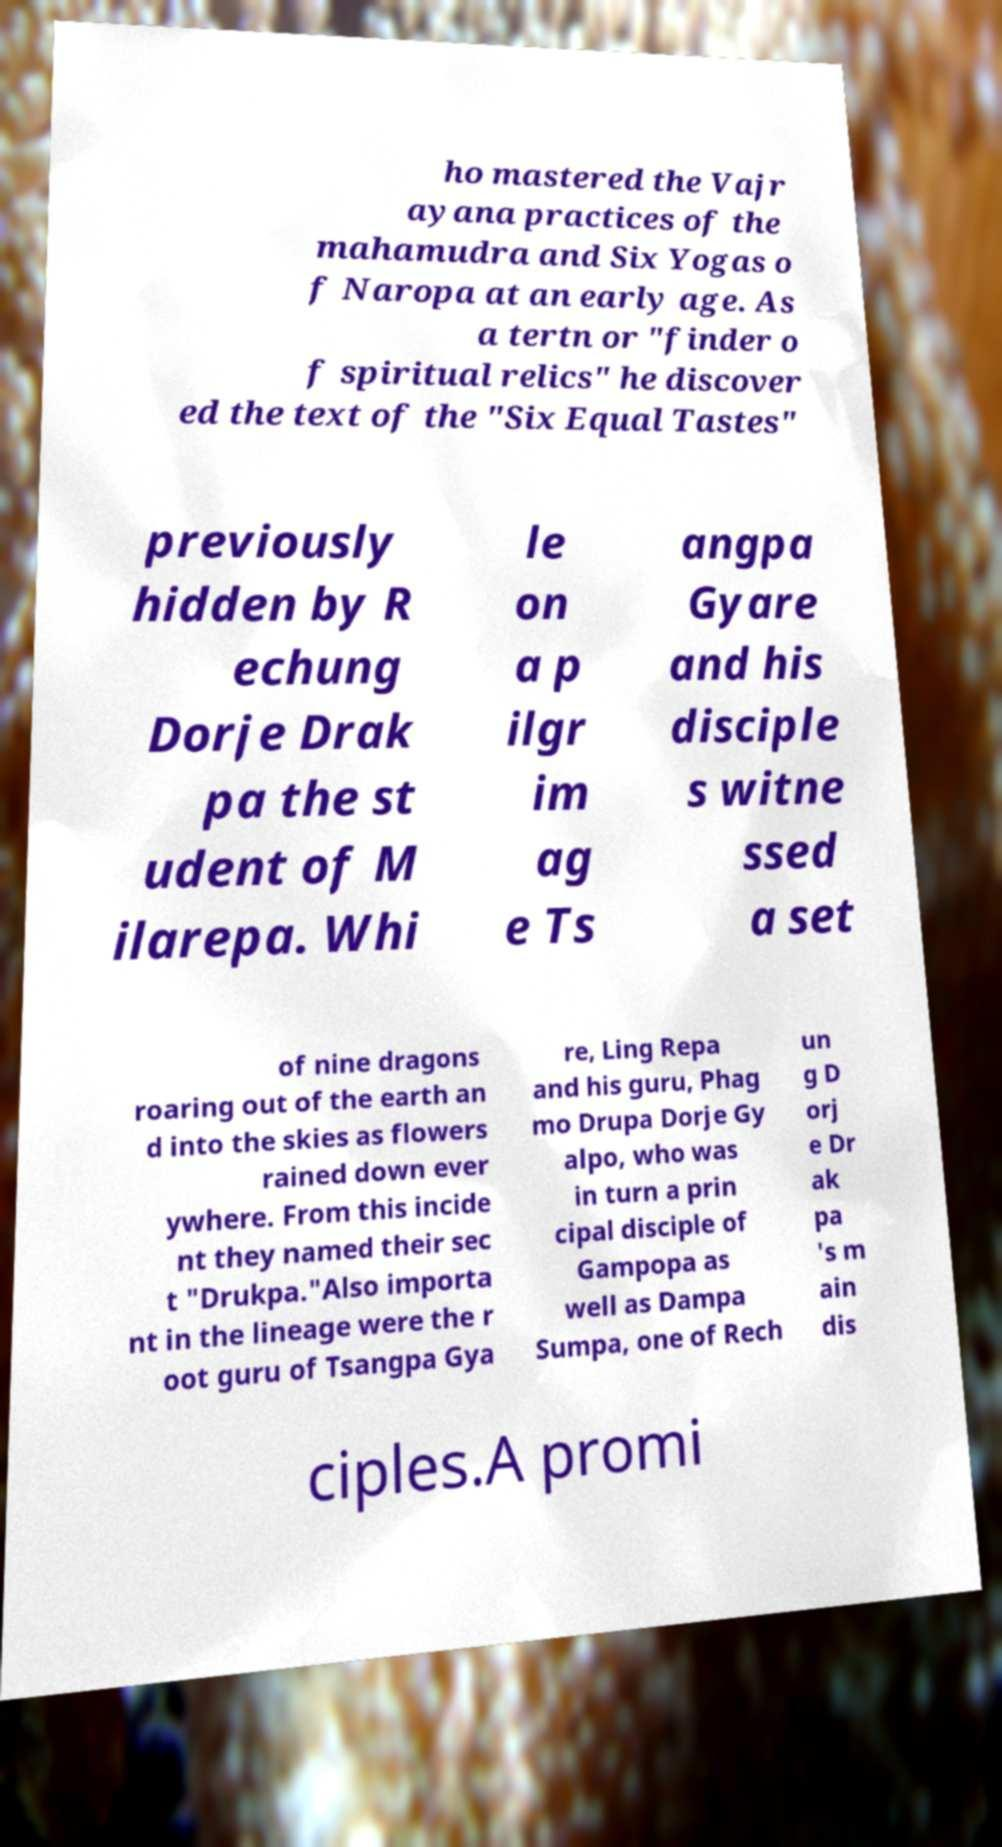Please identify and transcribe the text found in this image. ho mastered the Vajr ayana practices of the mahamudra and Six Yogas o f Naropa at an early age. As a tertn or "finder o f spiritual relics" he discover ed the text of the "Six Equal Tastes" previously hidden by R echung Dorje Drak pa the st udent of M ilarepa. Whi le on a p ilgr im ag e Ts angpa Gyare and his disciple s witne ssed a set of nine dragons roaring out of the earth an d into the skies as flowers rained down ever ywhere. From this incide nt they named their sec t "Drukpa."Also importa nt in the lineage were the r oot guru of Tsangpa Gya re, Ling Repa and his guru, Phag mo Drupa Dorje Gy alpo, who was in turn a prin cipal disciple of Gampopa as well as Dampa Sumpa, one of Rech un g D orj e Dr ak pa 's m ain dis ciples.A promi 